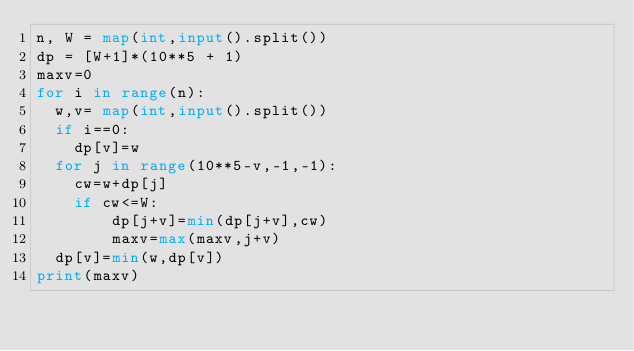Convert code to text. <code><loc_0><loc_0><loc_500><loc_500><_Python_>n, W = map(int,input().split())
dp = [W+1]*(10**5 + 1)
maxv=0
for i in range(n):
  w,v= map(int,input().split())
  if i==0:
  	dp[v]=w
  for j in range(10**5-v,-1,-1):
  	cw=w+dp[j]
  	if cw<=W:
  		dp[j+v]=min(dp[j+v],cw)
  		maxv=max(maxv,j+v)
  dp[v]=min(w,dp[v])
print(maxv)



			
		

 

</code> 